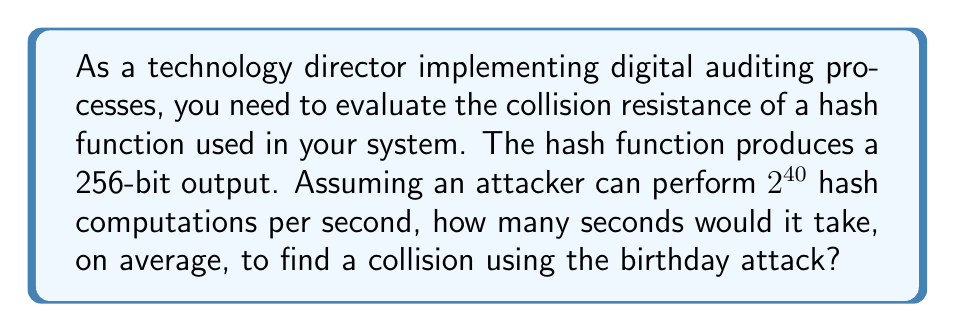Can you answer this question? To solve this problem, we'll follow these steps:

1) The birthday attack is based on the birthday paradox, which states that in a group of 23 people, there's a 50% chance that two people share the same birthday.

2) For a hash function with an n-bit output, the number of hash computations needed to find a collision with 50% probability is approximately $\sqrt{2^n}$.

3) In this case, n = 256, so the number of computations needed is:

   $$\sqrt{2^{256}} = 2^{128}$$

4) The attacker can perform $2^{40}$ computations per second. To find the time in seconds, we divide the total number of computations by the computations per second:

   $$\frac{2^{128}}{2^{40}} = 2^{128-40} = 2^{88}$$

5) To express this in scientific notation:

   $2^{88} \approx 3.09 \times 10^{26}$ seconds

This is an incredibly large number, demonstrating the strength of a 256-bit hash function against collision attacks.
Answer: $2^{88}$ seconds 